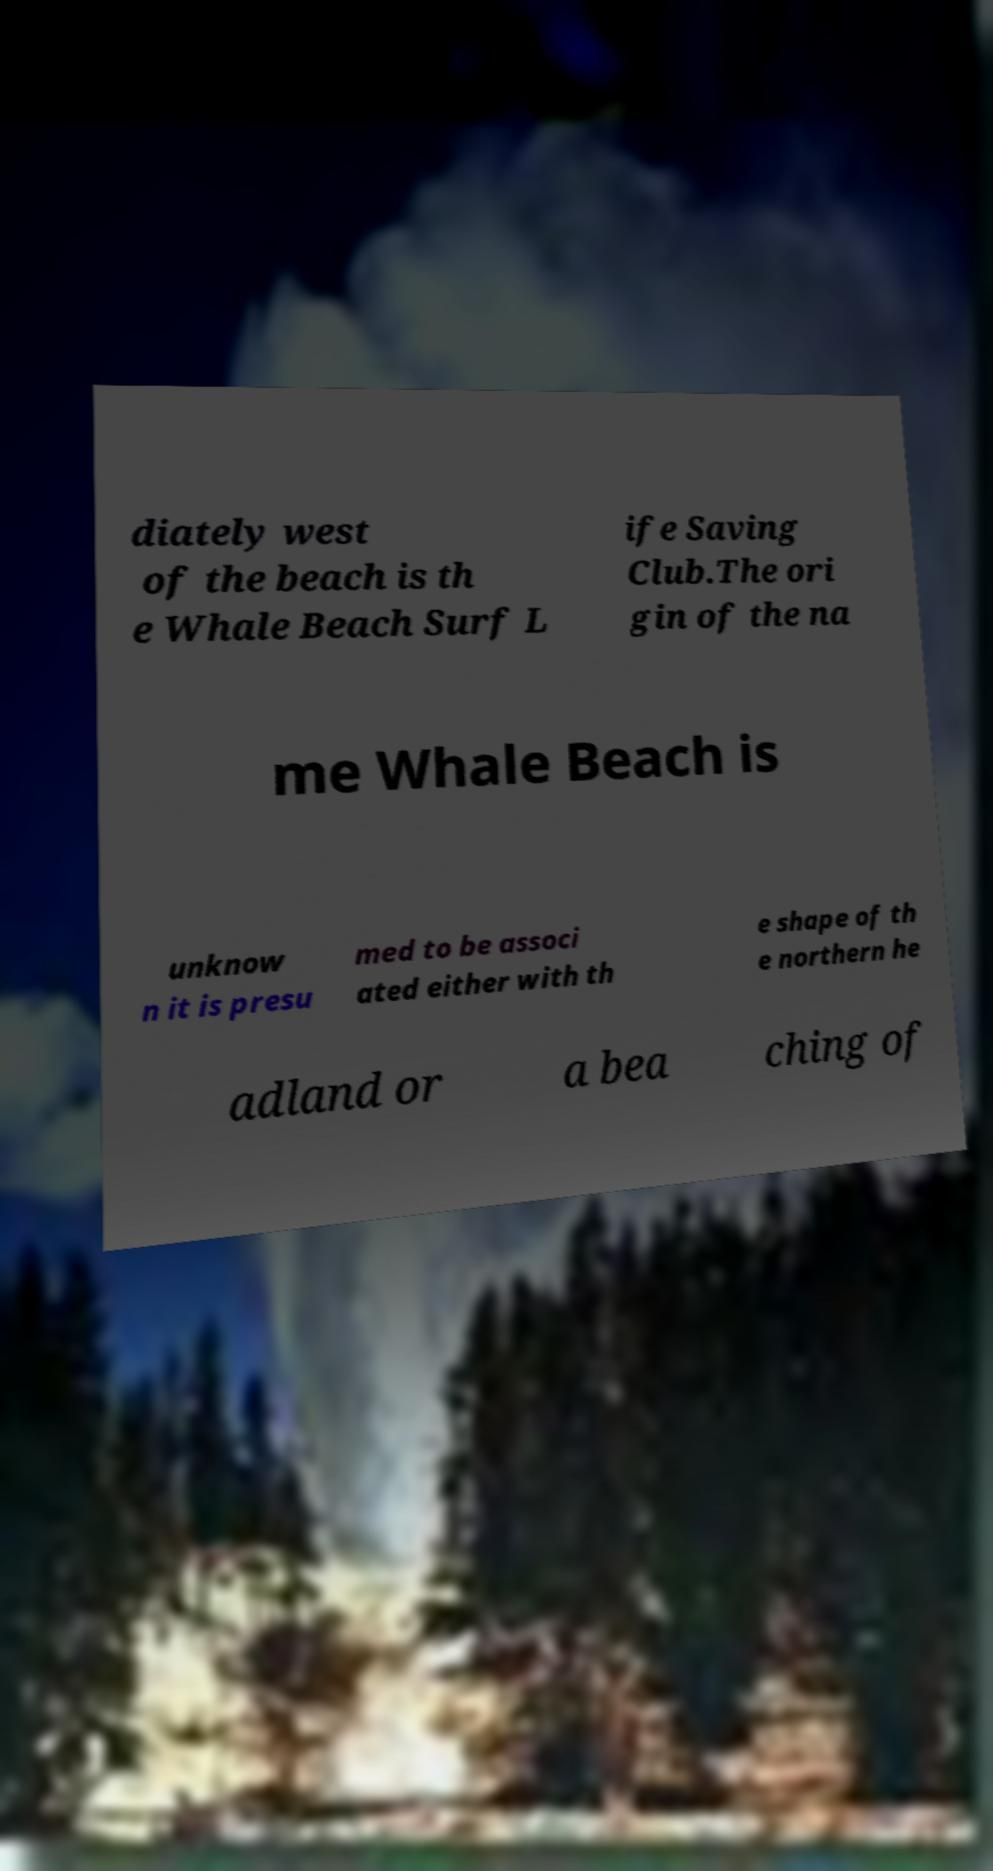Could you assist in decoding the text presented in this image and type it out clearly? diately west of the beach is th e Whale Beach Surf L ife Saving Club.The ori gin of the na me Whale Beach is unknow n it is presu med to be associ ated either with th e shape of th e northern he adland or a bea ching of 